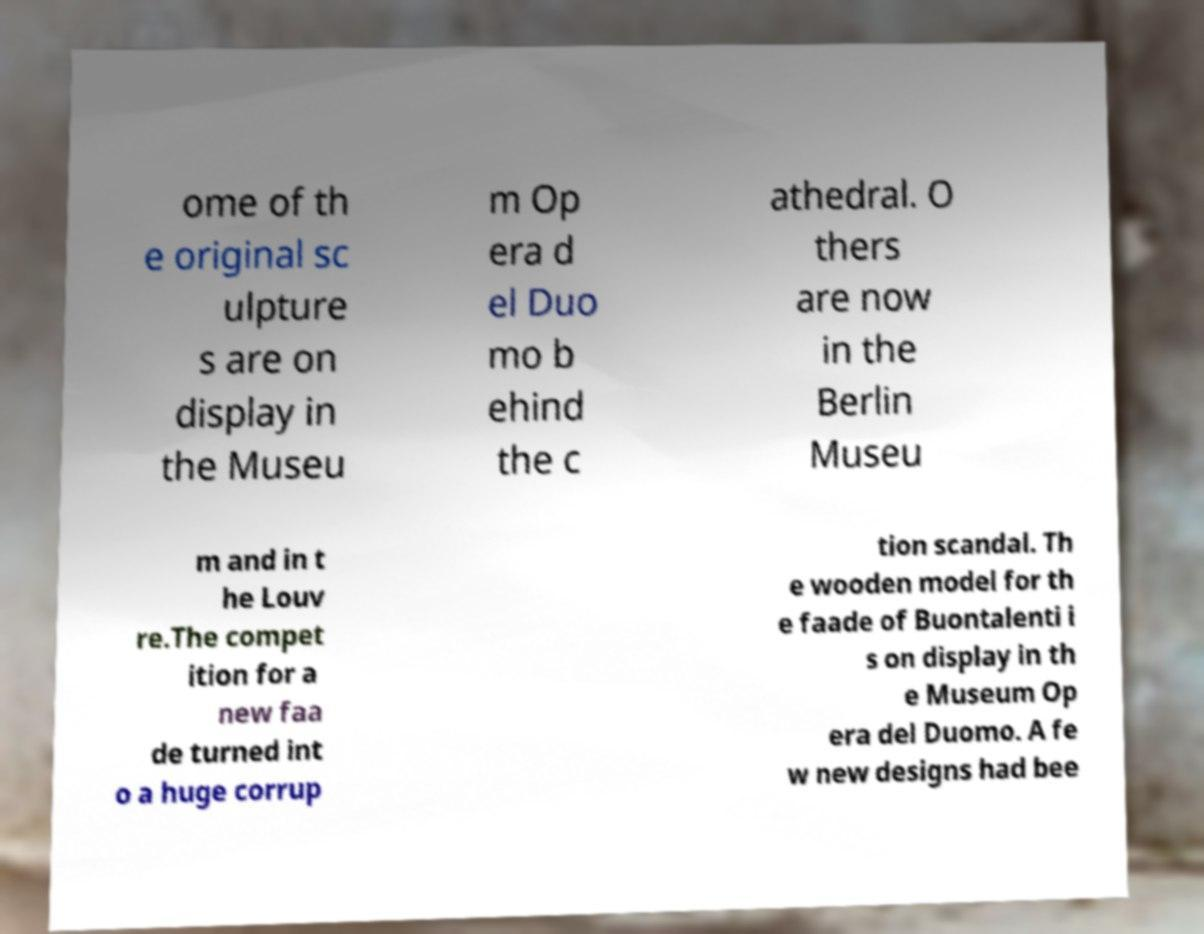Please identify and transcribe the text found in this image. ome of th e original sc ulpture s are on display in the Museu m Op era d el Duo mo b ehind the c athedral. O thers are now in the Berlin Museu m and in t he Louv re.The compet ition for a new faa de turned int o a huge corrup tion scandal. Th e wooden model for th e faade of Buontalenti i s on display in th e Museum Op era del Duomo. A fe w new designs had bee 